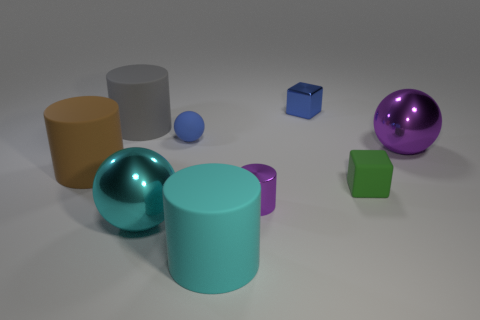Add 1 large cyan balls. How many objects exist? 10 Subtract all cylinders. How many objects are left? 5 Subtract 1 blue cubes. How many objects are left? 8 Subtract all big gray objects. Subtract all blue balls. How many objects are left? 7 Add 5 gray rubber things. How many gray rubber things are left? 6 Add 5 large cyan metal blocks. How many large cyan metal blocks exist? 5 